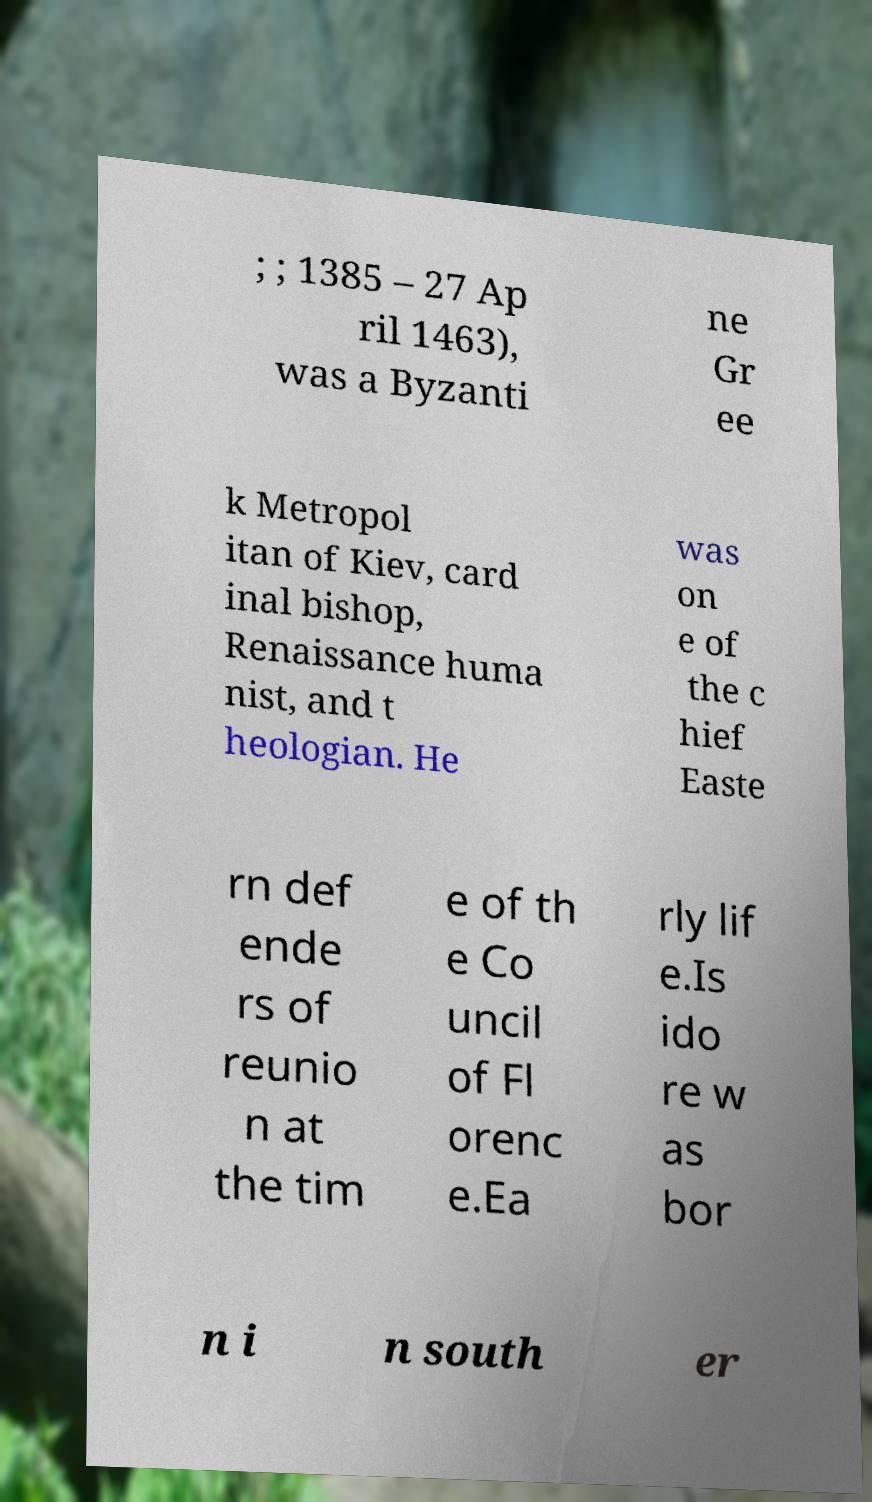Could you assist in decoding the text presented in this image and type it out clearly? ; ; 1385 – 27 Ap ril 1463), was a Byzanti ne Gr ee k Metropol itan of Kiev, card inal bishop, Renaissance huma nist, and t heologian. He was on e of the c hief Easte rn def ende rs of reunio n at the tim e of th e Co uncil of Fl orenc e.Ea rly lif e.Is ido re w as bor n i n south er 